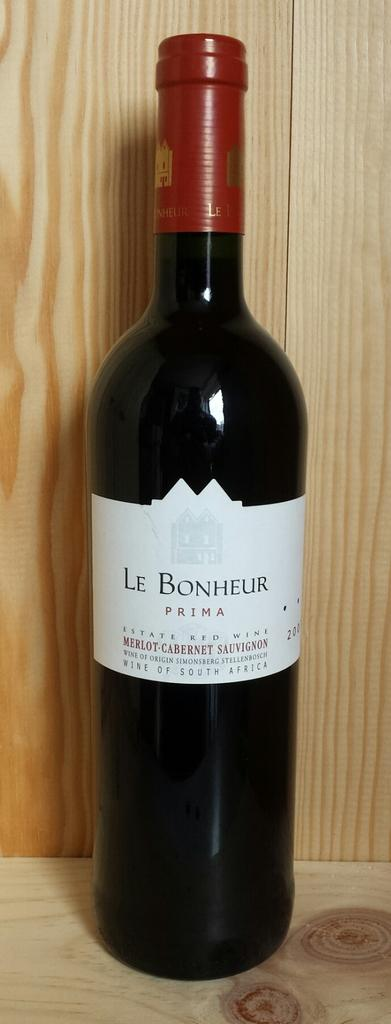<image>
Share a concise interpretation of the image provided. A bottle of Le Bonheur Merlot/Cabernet blend wine sits on a wooden shelf. 